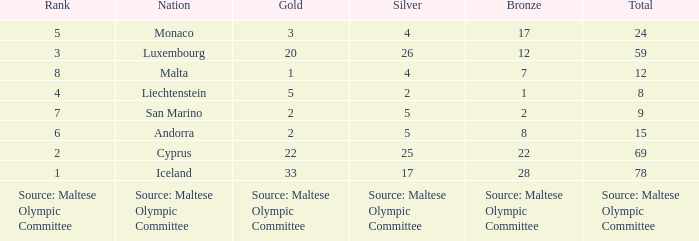What rank is the nation that has a bronze of source: Maltese Olympic Committee? Source: Maltese Olympic Committee. 